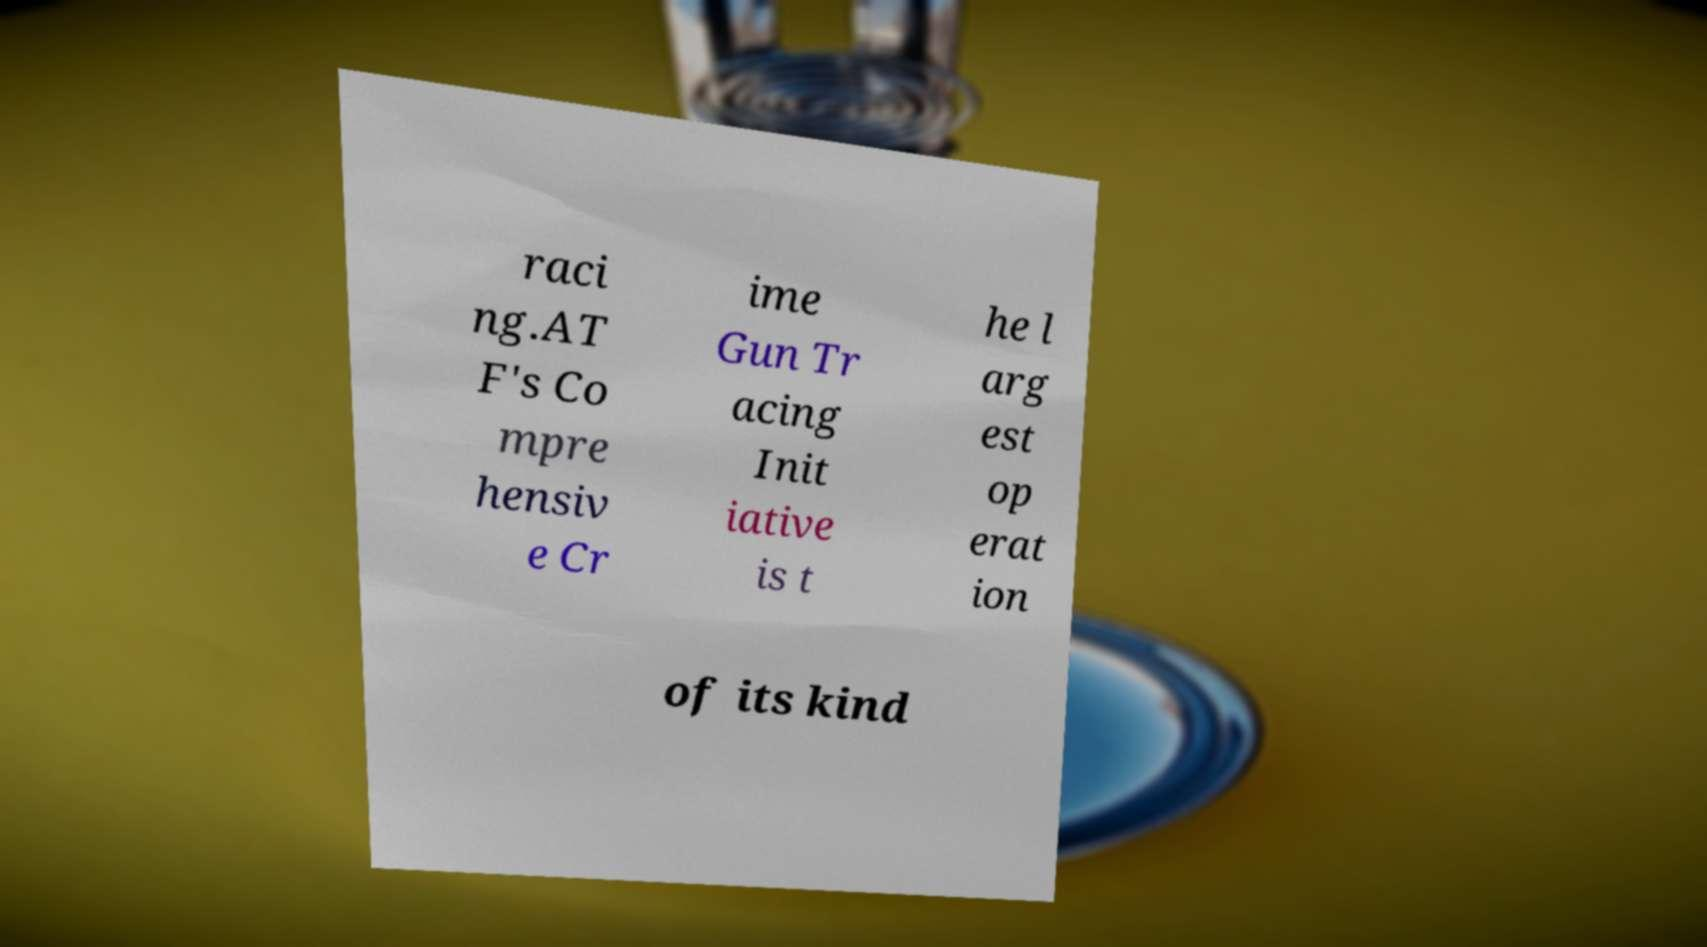Please read and relay the text visible in this image. What does it say? raci ng.AT F's Co mpre hensiv e Cr ime Gun Tr acing Init iative is t he l arg est op erat ion of its kind 